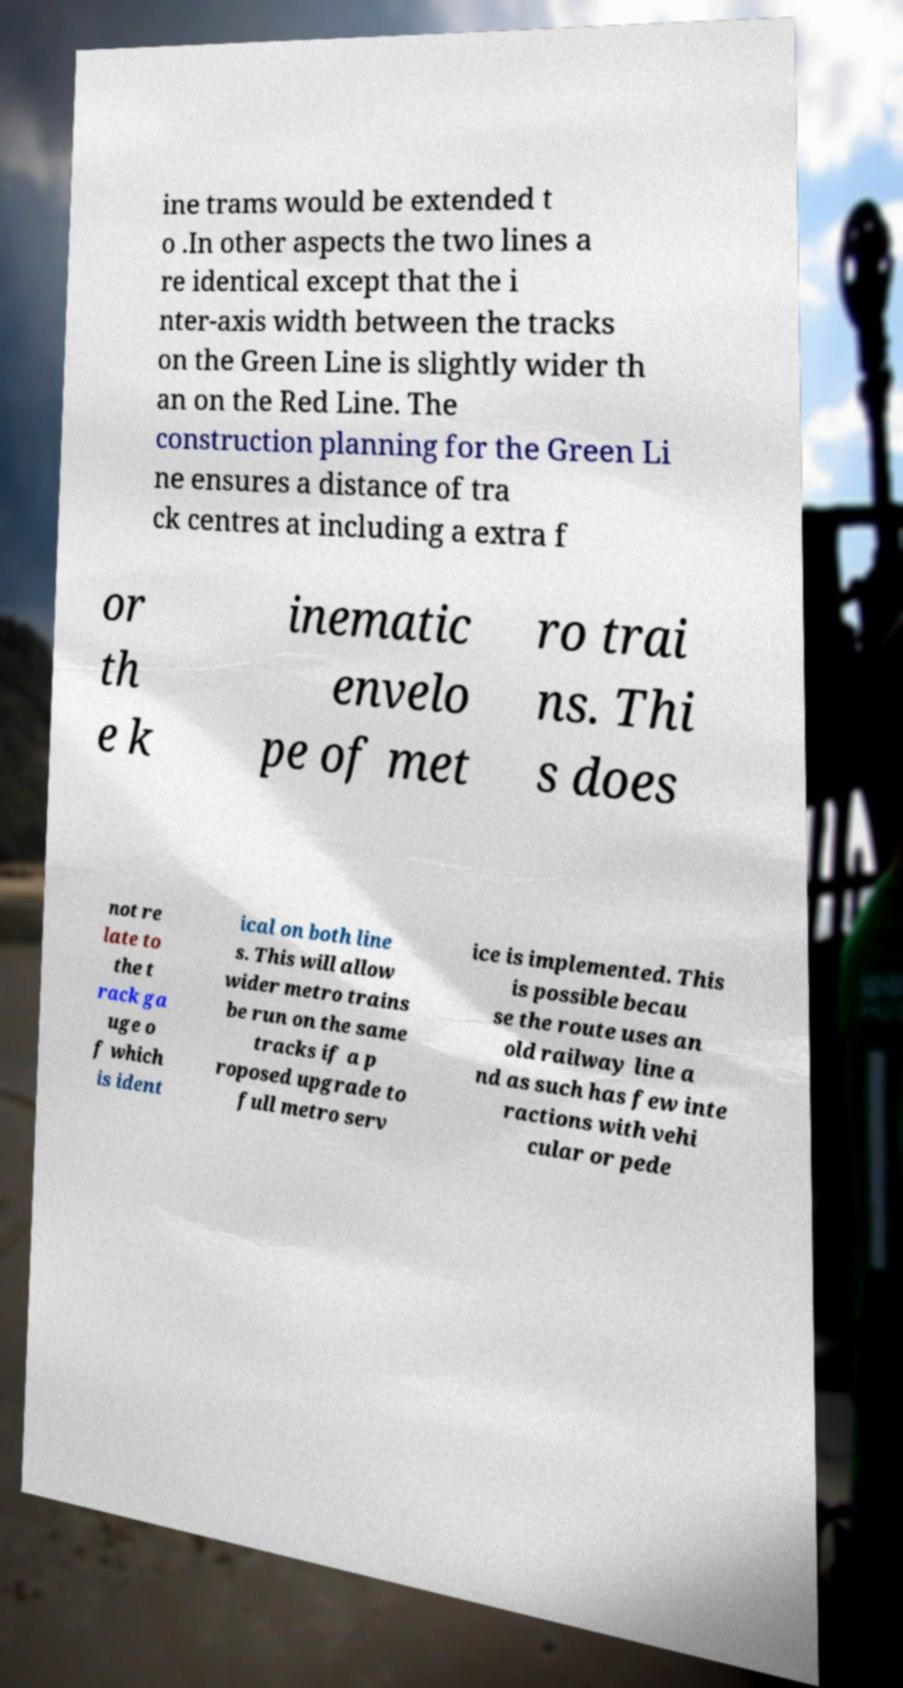Can you read and provide the text displayed in the image?This photo seems to have some interesting text. Can you extract and type it out for me? ine trams would be extended t o .In other aspects the two lines a re identical except that the i nter-axis width between the tracks on the Green Line is slightly wider th an on the Red Line. The construction planning for the Green Li ne ensures a distance of tra ck centres at including a extra f or th e k inematic envelo pe of met ro trai ns. Thi s does not re late to the t rack ga uge o f which is ident ical on both line s. This will allow wider metro trains be run on the same tracks if a p roposed upgrade to full metro serv ice is implemented. This is possible becau se the route uses an old railway line a nd as such has few inte ractions with vehi cular or pede 